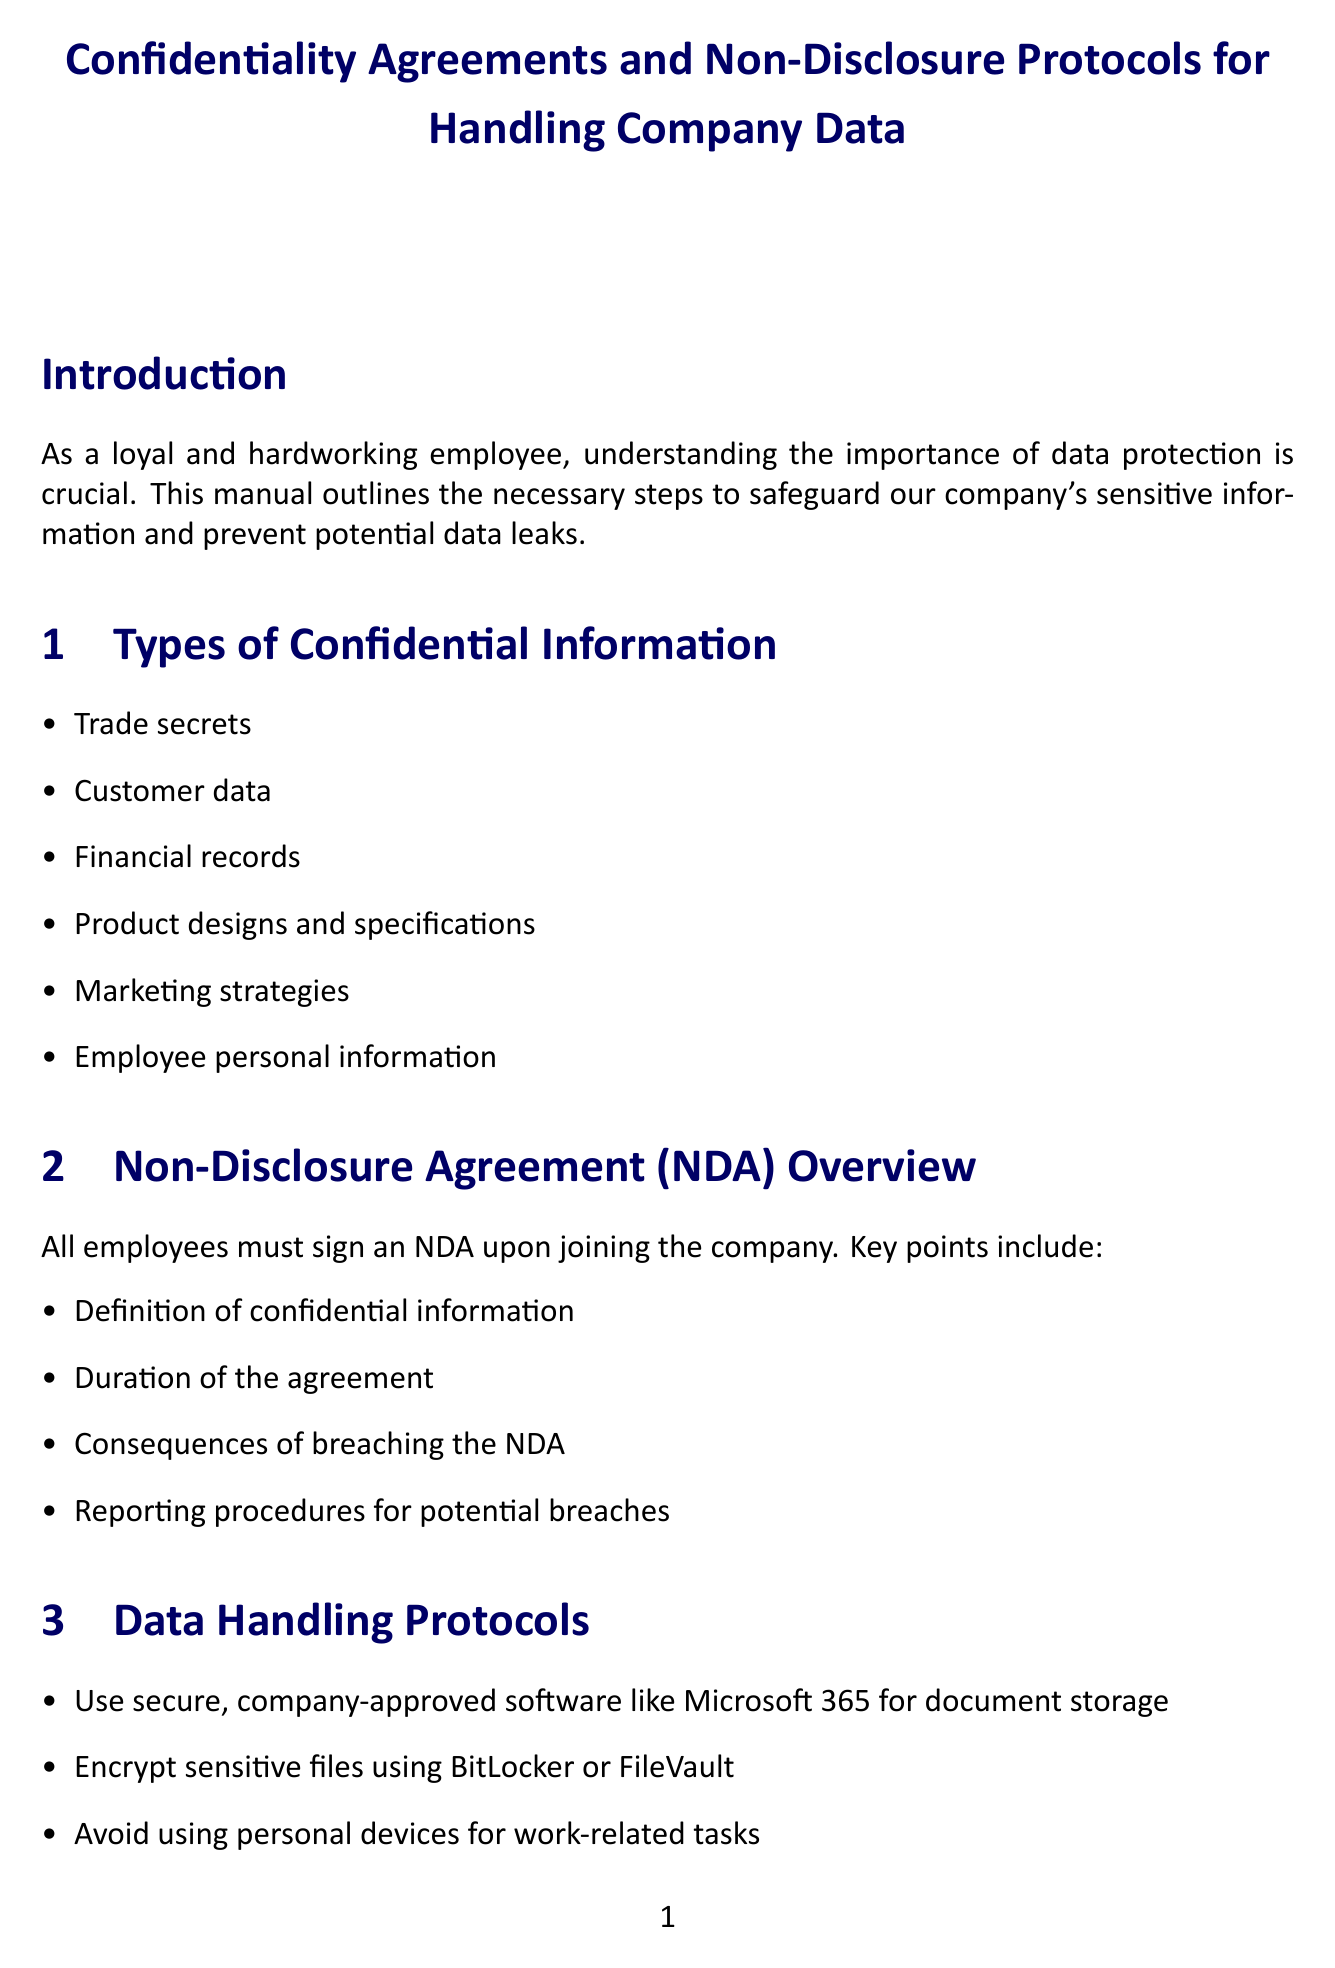What are the types of confidential information listed? The document contains a specific list of confidential information types, including trade secrets, customer data, and more.
Answer: Trade secrets, customer data, financial records, product designs and specifications, marketing strategies, employee personal information What must employees sign upon joining the company? The document states that all employees must sign a specific agreement when they are hired.
Answer: NDA What is one of the consequences of non-compliance? The document outlines several consequences for failing to comply with the guidelines provided.
Answer: Disciplinary action What should be used for encrypting sensitive messages? The document mentions a specific tool recommended for email communication involving confidential data.
Answer: Cisco Secure Email What should employees do immediately upon noticing a potential data breach? The document specifies an action that must be taken without delay when a potential data breach occurs.
Answer: Notify the IT Security team How often must employees complete security awareness training? The document indicates the frequency of mandatory training for employees regarding security.
Answer: Annually What is a recommended way to secure home Wi-Fi networks? The document offers a suggestion for improving home network security when working remotely.
Answer: WPA3 encryption What is the recommended action when stepping away from the computer? The document provides a security practice to follow in case the employee needs to leave their workspace temporarily.
Answer: Lock your computer screen 